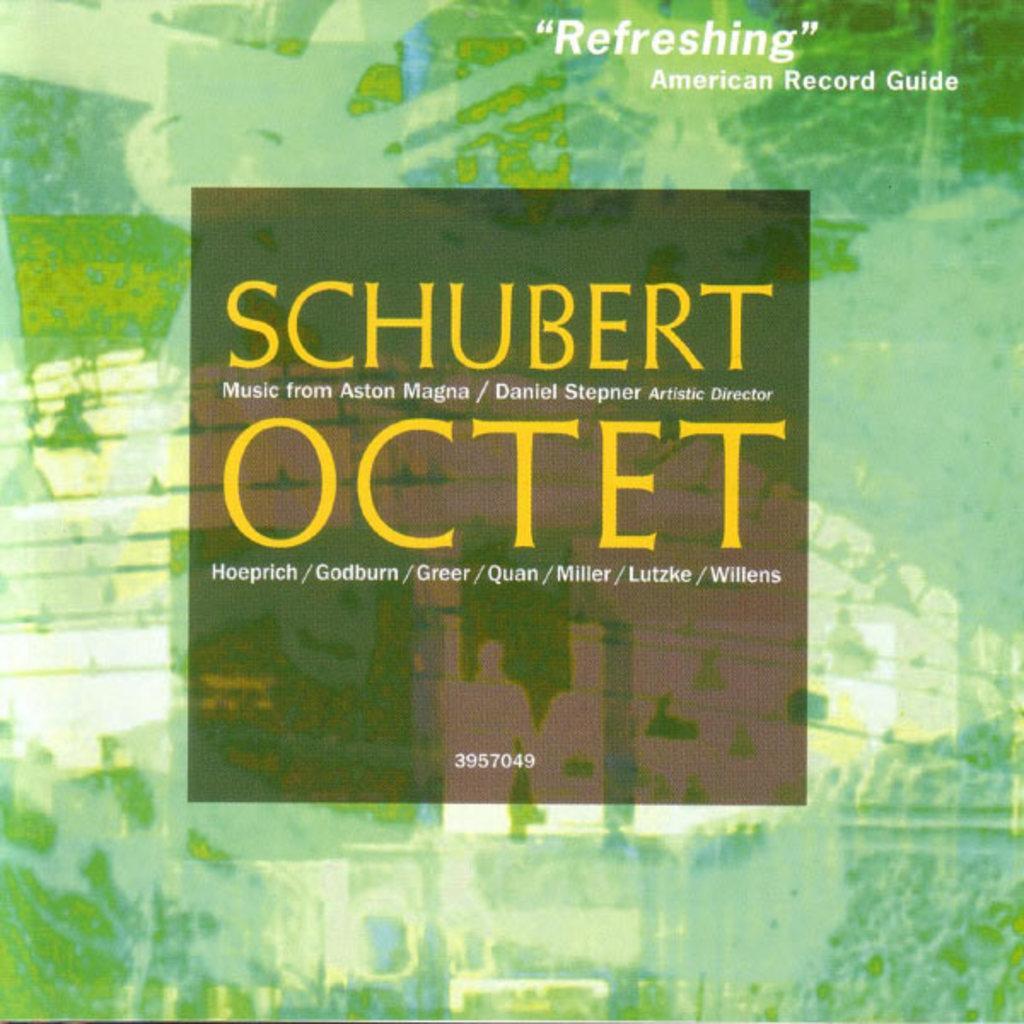Please provide a concise description of this image. This is a poster, in this image in the center there is some text and at the top of the image there is some text. 